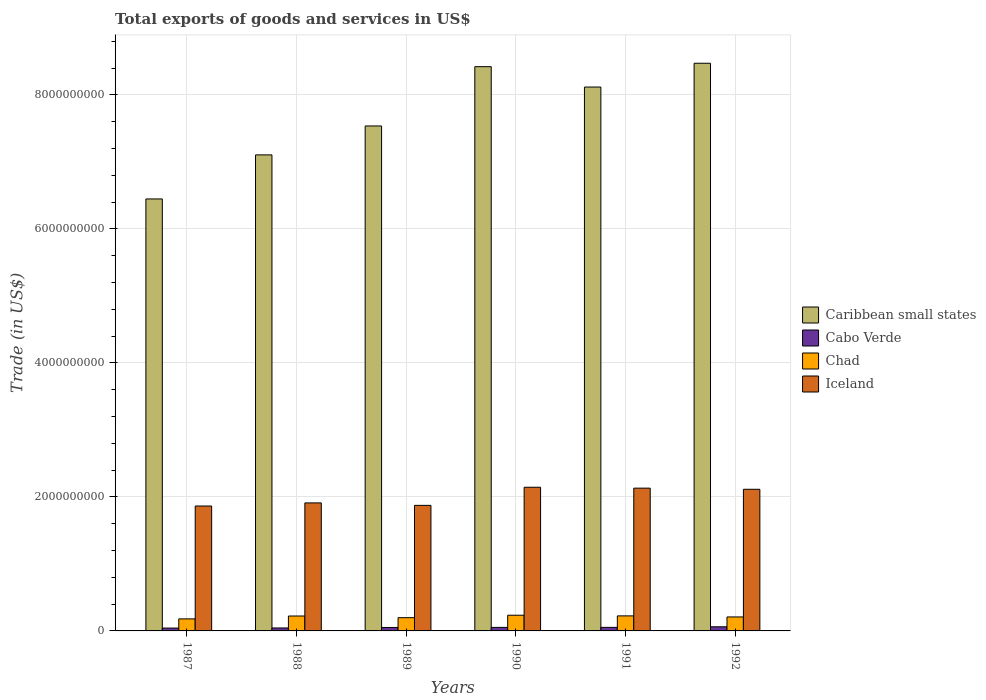How many different coloured bars are there?
Your answer should be compact. 4. How many groups of bars are there?
Your response must be concise. 6. Are the number of bars on each tick of the X-axis equal?
Make the answer very short. Yes. What is the total exports of goods and services in Caribbean small states in 1989?
Give a very brief answer. 7.54e+09. Across all years, what is the maximum total exports of goods and services in Cabo Verde?
Give a very brief answer. 6.17e+07. Across all years, what is the minimum total exports of goods and services in Iceland?
Offer a very short reply. 1.86e+09. In which year was the total exports of goods and services in Chad maximum?
Ensure brevity in your answer.  1990. What is the total total exports of goods and services in Cabo Verde in the graph?
Ensure brevity in your answer.  3.05e+08. What is the difference between the total exports of goods and services in Chad in 1987 and that in 1989?
Offer a very short reply. -1.78e+07. What is the difference between the total exports of goods and services in Chad in 1988 and the total exports of goods and services in Caribbean small states in 1990?
Ensure brevity in your answer.  -8.20e+09. What is the average total exports of goods and services in Chad per year?
Offer a terse response. 2.11e+08. In the year 1988, what is the difference between the total exports of goods and services in Cabo Verde and total exports of goods and services in Caribbean small states?
Provide a succinct answer. -7.06e+09. What is the ratio of the total exports of goods and services in Cabo Verde in 1989 to that in 1990?
Offer a very short reply. 0.98. Is the difference between the total exports of goods and services in Cabo Verde in 1987 and 1989 greater than the difference between the total exports of goods and services in Caribbean small states in 1987 and 1989?
Your response must be concise. Yes. What is the difference between the highest and the second highest total exports of goods and services in Cabo Verde?
Your answer should be compact. 8.75e+06. What is the difference between the highest and the lowest total exports of goods and services in Caribbean small states?
Give a very brief answer. 2.03e+09. What does the 3rd bar from the left in 1987 represents?
Your answer should be very brief. Chad. What does the 4th bar from the right in 1989 represents?
Your response must be concise. Caribbean small states. Is it the case that in every year, the sum of the total exports of goods and services in Cabo Verde and total exports of goods and services in Chad is greater than the total exports of goods and services in Iceland?
Your response must be concise. No. How many years are there in the graph?
Provide a short and direct response. 6. Are the values on the major ticks of Y-axis written in scientific E-notation?
Your answer should be very brief. No. Does the graph contain any zero values?
Provide a short and direct response. No. Does the graph contain grids?
Your answer should be compact. Yes. How are the legend labels stacked?
Offer a very short reply. Vertical. What is the title of the graph?
Give a very brief answer. Total exports of goods and services in US$. What is the label or title of the X-axis?
Make the answer very short. Years. What is the label or title of the Y-axis?
Provide a succinct answer. Trade (in US$). What is the Trade (in US$) in Caribbean small states in 1987?
Offer a terse response. 6.45e+09. What is the Trade (in US$) of Cabo Verde in 1987?
Provide a short and direct response. 4.26e+07. What is the Trade (in US$) in Chad in 1987?
Your answer should be compact. 1.80e+08. What is the Trade (in US$) of Iceland in 1987?
Offer a very short reply. 1.86e+09. What is the Trade (in US$) of Caribbean small states in 1988?
Make the answer very short. 7.11e+09. What is the Trade (in US$) of Cabo Verde in 1988?
Provide a succinct answer. 4.42e+07. What is the Trade (in US$) of Chad in 1988?
Your answer should be compact. 2.23e+08. What is the Trade (in US$) in Iceland in 1988?
Your response must be concise. 1.91e+09. What is the Trade (in US$) in Caribbean small states in 1989?
Keep it short and to the point. 7.54e+09. What is the Trade (in US$) in Cabo Verde in 1989?
Make the answer very short. 5.14e+07. What is the Trade (in US$) in Chad in 1989?
Ensure brevity in your answer.  1.98e+08. What is the Trade (in US$) of Iceland in 1989?
Ensure brevity in your answer.  1.87e+09. What is the Trade (in US$) in Caribbean small states in 1990?
Your answer should be compact. 8.42e+09. What is the Trade (in US$) of Cabo Verde in 1990?
Provide a short and direct response. 5.26e+07. What is the Trade (in US$) in Chad in 1990?
Give a very brief answer. 2.34e+08. What is the Trade (in US$) of Iceland in 1990?
Provide a succinct answer. 2.14e+09. What is the Trade (in US$) of Caribbean small states in 1991?
Ensure brevity in your answer.  8.12e+09. What is the Trade (in US$) of Cabo Verde in 1991?
Your response must be concise. 5.30e+07. What is the Trade (in US$) of Chad in 1991?
Offer a very short reply. 2.24e+08. What is the Trade (in US$) of Iceland in 1991?
Ensure brevity in your answer.  2.13e+09. What is the Trade (in US$) of Caribbean small states in 1992?
Give a very brief answer. 8.47e+09. What is the Trade (in US$) in Cabo Verde in 1992?
Your response must be concise. 6.17e+07. What is the Trade (in US$) in Chad in 1992?
Provide a succinct answer. 2.09e+08. What is the Trade (in US$) of Iceland in 1992?
Ensure brevity in your answer.  2.11e+09. Across all years, what is the maximum Trade (in US$) in Caribbean small states?
Your response must be concise. 8.47e+09. Across all years, what is the maximum Trade (in US$) in Cabo Verde?
Your answer should be compact. 6.17e+07. Across all years, what is the maximum Trade (in US$) in Chad?
Your answer should be compact. 2.34e+08. Across all years, what is the maximum Trade (in US$) in Iceland?
Make the answer very short. 2.14e+09. Across all years, what is the minimum Trade (in US$) of Caribbean small states?
Your answer should be compact. 6.45e+09. Across all years, what is the minimum Trade (in US$) of Cabo Verde?
Provide a short and direct response. 4.26e+07. Across all years, what is the minimum Trade (in US$) of Chad?
Ensure brevity in your answer.  1.80e+08. Across all years, what is the minimum Trade (in US$) of Iceland?
Offer a terse response. 1.86e+09. What is the total Trade (in US$) in Caribbean small states in the graph?
Your answer should be very brief. 4.61e+1. What is the total Trade (in US$) of Cabo Verde in the graph?
Ensure brevity in your answer.  3.05e+08. What is the total Trade (in US$) of Chad in the graph?
Provide a short and direct response. 1.27e+09. What is the total Trade (in US$) in Iceland in the graph?
Ensure brevity in your answer.  1.20e+1. What is the difference between the Trade (in US$) in Caribbean small states in 1987 and that in 1988?
Keep it short and to the point. -6.58e+08. What is the difference between the Trade (in US$) in Cabo Verde in 1987 and that in 1988?
Provide a succinct answer. -1.58e+06. What is the difference between the Trade (in US$) of Chad in 1987 and that in 1988?
Give a very brief answer. -4.29e+07. What is the difference between the Trade (in US$) in Iceland in 1987 and that in 1988?
Ensure brevity in your answer.  -4.64e+07. What is the difference between the Trade (in US$) in Caribbean small states in 1987 and that in 1989?
Your answer should be very brief. -1.09e+09. What is the difference between the Trade (in US$) in Cabo Verde in 1987 and that in 1989?
Make the answer very short. -8.84e+06. What is the difference between the Trade (in US$) of Chad in 1987 and that in 1989?
Your response must be concise. -1.78e+07. What is the difference between the Trade (in US$) of Iceland in 1987 and that in 1989?
Your answer should be very brief. -9.49e+06. What is the difference between the Trade (in US$) in Caribbean small states in 1987 and that in 1990?
Keep it short and to the point. -1.97e+09. What is the difference between the Trade (in US$) of Cabo Verde in 1987 and that in 1990?
Ensure brevity in your answer.  -1.00e+07. What is the difference between the Trade (in US$) of Chad in 1987 and that in 1990?
Your response must be concise. -5.46e+07. What is the difference between the Trade (in US$) of Iceland in 1987 and that in 1990?
Provide a succinct answer. -2.80e+08. What is the difference between the Trade (in US$) in Caribbean small states in 1987 and that in 1991?
Your answer should be very brief. -1.67e+09. What is the difference between the Trade (in US$) of Cabo Verde in 1987 and that in 1991?
Make the answer very short. -1.04e+07. What is the difference between the Trade (in US$) in Chad in 1987 and that in 1991?
Make the answer very short. -4.46e+07. What is the difference between the Trade (in US$) of Iceland in 1987 and that in 1991?
Provide a succinct answer. -2.66e+08. What is the difference between the Trade (in US$) in Caribbean small states in 1987 and that in 1992?
Your answer should be very brief. -2.03e+09. What is the difference between the Trade (in US$) of Cabo Verde in 1987 and that in 1992?
Keep it short and to the point. -1.91e+07. What is the difference between the Trade (in US$) in Chad in 1987 and that in 1992?
Your answer should be very brief. -2.90e+07. What is the difference between the Trade (in US$) of Iceland in 1987 and that in 1992?
Keep it short and to the point. -2.49e+08. What is the difference between the Trade (in US$) in Caribbean small states in 1988 and that in 1989?
Make the answer very short. -4.32e+08. What is the difference between the Trade (in US$) of Cabo Verde in 1988 and that in 1989?
Your answer should be compact. -7.26e+06. What is the difference between the Trade (in US$) of Chad in 1988 and that in 1989?
Give a very brief answer. 2.51e+07. What is the difference between the Trade (in US$) of Iceland in 1988 and that in 1989?
Give a very brief answer. 3.69e+07. What is the difference between the Trade (in US$) in Caribbean small states in 1988 and that in 1990?
Offer a terse response. -1.32e+09. What is the difference between the Trade (in US$) in Cabo Verde in 1988 and that in 1990?
Make the answer very short. -8.42e+06. What is the difference between the Trade (in US$) of Chad in 1988 and that in 1990?
Provide a succinct answer. -1.17e+07. What is the difference between the Trade (in US$) in Iceland in 1988 and that in 1990?
Give a very brief answer. -2.33e+08. What is the difference between the Trade (in US$) of Caribbean small states in 1988 and that in 1991?
Keep it short and to the point. -1.01e+09. What is the difference between the Trade (in US$) in Cabo Verde in 1988 and that in 1991?
Provide a succinct answer. -8.82e+06. What is the difference between the Trade (in US$) of Chad in 1988 and that in 1991?
Ensure brevity in your answer.  -1.68e+06. What is the difference between the Trade (in US$) of Iceland in 1988 and that in 1991?
Provide a succinct answer. -2.20e+08. What is the difference between the Trade (in US$) in Caribbean small states in 1988 and that in 1992?
Your response must be concise. -1.37e+09. What is the difference between the Trade (in US$) of Cabo Verde in 1988 and that in 1992?
Provide a short and direct response. -1.76e+07. What is the difference between the Trade (in US$) in Chad in 1988 and that in 1992?
Your answer should be very brief. 1.40e+07. What is the difference between the Trade (in US$) in Iceland in 1988 and that in 1992?
Provide a succinct answer. -2.03e+08. What is the difference between the Trade (in US$) of Caribbean small states in 1989 and that in 1990?
Keep it short and to the point. -8.85e+08. What is the difference between the Trade (in US$) of Cabo Verde in 1989 and that in 1990?
Provide a succinct answer. -1.16e+06. What is the difference between the Trade (in US$) in Chad in 1989 and that in 1990?
Your answer should be compact. -3.68e+07. What is the difference between the Trade (in US$) of Iceland in 1989 and that in 1990?
Offer a terse response. -2.70e+08. What is the difference between the Trade (in US$) of Caribbean small states in 1989 and that in 1991?
Provide a succinct answer. -5.81e+08. What is the difference between the Trade (in US$) in Cabo Verde in 1989 and that in 1991?
Offer a very short reply. -1.56e+06. What is the difference between the Trade (in US$) of Chad in 1989 and that in 1991?
Ensure brevity in your answer.  -2.68e+07. What is the difference between the Trade (in US$) of Iceland in 1989 and that in 1991?
Ensure brevity in your answer.  -2.57e+08. What is the difference between the Trade (in US$) of Caribbean small states in 1989 and that in 1992?
Offer a very short reply. -9.36e+08. What is the difference between the Trade (in US$) of Cabo Verde in 1989 and that in 1992?
Your response must be concise. -1.03e+07. What is the difference between the Trade (in US$) in Chad in 1989 and that in 1992?
Provide a short and direct response. -1.11e+07. What is the difference between the Trade (in US$) in Iceland in 1989 and that in 1992?
Keep it short and to the point. -2.40e+08. What is the difference between the Trade (in US$) of Caribbean small states in 1990 and that in 1991?
Ensure brevity in your answer.  3.04e+08. What is the difference between the Trade (in US$) in Cabo Verde in 1990 and that in 1991?
Your answer should be very brief. -4.00e+05. What is the difference between the Trade (in US$) in Chad in 1990 and that in 1991?
Provide a short and direct response. 1.00e+07. What is the difference between the Trade (in US$) in Iceland in 1990 and that in 1991?
Provide a short and direct response. 1.34e+07. What is the difference between the Trade (in US$) of Caribbean small states in 1990 and that in 1992?
Provide a succinct answer. -5.09e+07. What is the difference between the Trade (in US$) in Cabo Verde in 1990 and that in 1992?
Your response must be concise. -9.15e+06. What is the difference between the Trade (in US$) of Chad in 1990 and that in 1992?
Your answer should be very brief. 2.57e+07. What is the difference between the Trade (in US$) of Iceland in 1990 and that in 1992?
Offer a terse response. 3.05e+07. What is the difference between the Trade (in US$) in Caribbean small states in 1991 and that in 1992?
Offer a terse response. -3.55e+08. What is the difference between the Trade (in US$) of Cabo Verde in 1991 and that in 1992?
Provide a succinct answer. -8.75e+06. What is the difference between the Trade (in US$) of Chad in 1991 and that in 1992?
Offer a very short reply. 1.56e+07. What is the difference between the Trade (in US$) in Iceland in 1991 and that in 1992?
Keep it short and to the point. 1.71e+07. What is the difference between the Trade (in US$) in Caribbean small states in 1987 and the Trade (in US$) in Cabo Verde in 1988?
Provide a short and direct response. 6.40e+09. What is the difference between the Trade (in US$) of Caribbean small states in 1987 and the Trade (in US$) of Chad in 1988?
Ensure brevity in your answer.  6.22e+09. What is the difference between the Trade (in US$) in Caribbean small states in 1987 and the Trade (in US$) in Iceland in 1988?
Offer a terse response. 4.54e+09. What is the difference between the Trade (in US$) in Cabo Verde in 1987 and the Trade (in US$) in Chad in 1988?
Your answer should be very brief. -1.80e+08. What is the difference between the Trade (in US$) of Cabo Verde in 1987 and the Trade (in US$) of Iceland in 1988?
Make the answer very short. -1.87e+09. What is the difference between the Trade (in US$) of Chad in 1987 and the Trade (in US$) of Iceland in 1988?
Keep it short and to the point. -1.73e+09. What is the difference between the Trade (in US$) in Caribbean small states in 1987 and the Trade (in US$) in Cabo Verde in 1989?
Give a very brief answer. 6.40e+09. What is the difference between the Trade (in US$) in Caribbean small states in 1987 and the Trade (in US$) in Chad in 1989?
Provide a succinct answer. 6.25e+09. What is the difference between the Trade (in US$) in Caribbean small states in 1987 and the Trade (in US$) in Iceland in 1989?
Your answer should be compact. 4.57e+09. What is the difference between the Trade (in US$) of Cabo Verde in 1987 and the Trade (in US$) of Chad in 1989?
Offer a terse response. -1.55e+08. What is the difference between the Trade (in US$) of Cabo Verde in 1987 and the Trade (in US$) of Iceland in 1989?
Your response must be concise. -1.83e+09. What is the difference between the Trade (in US$) in Chad in 1987 and the Trade (in US$) in Iceland in 1989?
Make the answer very short. -1.69e+09. What is the difference between the Trade (in US$) of Caribbean small states in 1987 and the Trade (in US$) of Cabo Verde in 1990?
Offer a terse response. 6.40e+09. What is the difference between the Trade (in US$) in Caribbean small states in 1987 and the Trade (in US$) in Chad in 1990?
Make the answer very short. 6.21e+09. What is the difference between the Trade (in US$) of Caribbean small states in 1987 and the Trade (in US$) of Iceland in 1990?
Make the answer very short. 4.30e+09. What is the difference between the Trade (in US$) in Cabo Verde in 1987 and the Trade (in US$) in Chad in 1990?
Keep it short and to the point. -1.92e+08. What is the difference between the Trade (in US$) of Cabo Verde in 1987 and the Trade (in US$) of Iceland in 1990?
Make the answer very short. -2.10e+09. What is the difference between the Trade (in US$) of Chad in 1987 and the Trade (in US$) of Iceland in 1990?
Keep it short and to the point. -1.96e+09. What is the difference between the Trade (in US$) of Caribbean small states in 1987 and the Trade (in US$) of Cabo Verde in 1991?
Provide a succinct answer. 6.39e+09. What is the difference between the Trade (in US$) in Caribbean small states in 1987 and the Trade (in US$) in Chad in 1991?
Your response must be concise. 6.22e+09. What is the difference between the Trade (in US$) in Caribbean small states in 1987 and the Trade (in US$) in Iceland in 1991?
Make the answer very short. 4.32e+09. What is the difference between the Trade (in US$) of Cabo Verde in 1987 and the Trade (in US$) of Chad in 1991?
Keep it short and to the point. -1.82e+08. What is the difference between the Trade (in US$) of Cabo Verde in 1987 and the Trade (in US$) of Iceland in 1991?
Make the answer very short. -2.09e+09. What is the difference between the Trade (in US$) in Chad in 1987 and the Trade (in US$) in Iceland in 1991?
Offer a terse response. -1.95e+09. What is the difference between the Trade (in US$) in Caribbean small states in 1987 and the Trade (in US$) in Cabo Verde in 1992?
Offer a terse response. 6.39e+09. What is the difference between the Trade (in US$) of Caribbean small states in 1987 and the Trade (in US$) of Chad in 1992?
Give a very brief answer. 6.24e+09. What is the difference between the Trade (in US$) of Caribbean small states in 1987 and the Trade (in US$) of Iceland in 1992?
Offer a very short reply. 4.33e+09. What is the difference between the Trade (in US$) of Cabo Verde in 1987 and the Trade (in US$) of Chad in 1992?
Your answer should be very brief. -1.66e+08. What is the difference between the Trade (in US$) of Cabo Verde in 1987 and the Trade (in US$) of Iceland in 1992?
Make the answer very short. -2.07e+09. What is the difference between the Trade (in US$) in Chad in 1987 and the Trade (in US$) in Iceland in 1992?
Provide a short and direct response. -1.93e+09. What is the difference between the Trade (in US$) of Caribbean small states in 1988 and the Trade (in US$) of Cabo Verde in 1989?
Your response must be concise. 7.05e+09. What is the difference between the Trade (in US$) of Caribbean small states in 1988 and the Trade (in US$) of Chad in 1989?
Make the answer very short. 6.91e+09. What is the difference between the Trade (in US$) of Caribbean small states in 1988 and the Trade (in US$) of Iceland in 1989?
Provide a succinct answer. 5.23e+09. What is the difference between the Trade (in US$) of Cabo Verde in 1988 and the Trade (in US$) of Chad in 1989?
Ensure brevity in your answer.  -1.53e+08. What is the difference between the Trade (in US$) in Cabo Verde in 1988 and the Trade (in US$) in Iceland in 1989?
Ensure brevity in your answer.  -1.83e+09. What is the difference between the Trade (in US$) of Chad in 1988 and the Trade (in US$) of Iceland in 1989?
Offer a terse response. -1.65e+09. What is the difference between the Trade (in US$) in Caribbean small states in 1988 and the Trade (in US$) in Cabo Verde in 1990?
Your response must be concise. 7.05e+09. What is the difference between the Trade (in US$) of Caribbean small states in 1988 and the Trade (in US$) of Chad in 1990?
Ensure brevity in your answer.  6.87e+09. What is the difference between the Trade (in US$) of Caribbean small states in 1988 and the Trade (in US$) of Iceland in 1990?
Provide a short and direct response. 4.96e+09. What is the difference between the Trade (in US$) of Cabo Verde in 1988 and the Trade (in US$) of Chad in 1990?
Keep it short and to the point. -1.90e+08. What is the difference between the Trade (in US$) in Cabo Verde in 1988 and the Trade (in US$) in Iceland in 1990?
Provide a short and direct response. -2.10e+09. What is the difference between the Trade (in US$) in Chad in 1988 and the Trade (in US$) in Iceland in 1990?
Keep it short and to the point. -1.92e+09. What is the difference between the Trade (in US$) of Caribbean small states in 1988 and the Trade (in US$) of Cabo Verde in 1991?
Ensure brevity in your answer.  7.05e+09. What is the difference between the Trade (in US$) of Caribbean small states in 1988 and the Trade (in US$) of Chad in 1991?
Keep it short and to the point. 6.88e+09. What is the difference between the Trade (in US$) in Caribbean small states in 1988 and the Trade (in US$) in Iceland in 1991?
Ensure brevity in your answer.  4.97e+09. What is the difference between the Trade (in US$) in Cabo Verde in 1988 and the Trade (in US$) in Chad in 1991?
Give a very brief answer. -1.80e+08. What is the difference between the Trade (in US$) of Cabo Verde in 1988 and the Trade (in US$) of Iceland in 1991?
Your answer should be compact. -2.09e+09. What is the difference between the Trade (in US$) in Chad in 1988 and the Trade (in US$) in Iceland in 1991?
Your answer should be compact. -1.91e+09. What is the difference between the Trade (in US$) of Caribbean small states in 1988 and the Trade (in US$) of Cabo Verde in 1992?
Ensure brevity in your answer.  7.04e+09. What is the difference between the Trade (in US$) in Caribbean small states in 1988 and the Trade (in US$) in Chad in 1992?
Your answer should be very brief. 6.90e+09. What is the difference between the Trade (in US$) of Caribbean small states in 1988 and the Trade (in US$) of Iceland in 1992?
Your response must be concise. 4.99e+09. What is the difference between the Trade (in US$) of Cabo Verde in 1988 and the Trade (in US$) of Chad in 1992?
Your answer should be compact. -1.65e+08. What is the difference between the Trade (in US$) of Cabo Verde in 1988 and the Trade (in US$) of Iceland in 1992?
Offer a very short reply. -2.07e+09. What is the difference between the Trade (in US$) of Chad in 1988 and the Trade (in US$) of Iceland in 1992?
Give a very brief answer. -1.89e+09. What is the difference between the Trade (in US$) in Caribbean small states in 1989 and the Trade (in US$) in Cabo Verde in 1990?
Offer a terse response. 7.48e+09. What is the difference between the Trade (in US$) of Caribbean small states in 1989 and the Trade (in US$) of Chad in 1990?
Give a very brief answer. 7.30e+09. What is the difference between the Trade (in US$) of Caribbean small states in 1989 and the Trade (in US$) of Iceland in 1990?
Offer a very short reply. 5.39e+09. What is the difference between the Trade (in US$) of Cabo Verde in 1989 and the Trade (in US$) of Chad in 1990?
Give a very brief answer. -1.83e+08. What is the difference between the Trade (in US$) of Cabo Verde in 1989 and the Trade (in US$) of Iceland in 1990?
Offer a very short reply. -2.09e+09. What is the difference between the Trade (in US$) in Chad in 1989 and the Trade (in US$) in Iceland in 1990?
Make the answer very short. -1.95e+09. What is the difference between the Trade (in US$) in Caribbean small states in 1989 and the Trade (in US$) in Cabo Verde in 1991?
Provide a short and direct response. 7.48e+09. What is the difference between the Trade (in US$) of Caribbean small states in 1989 and the Trade (in US$) of Chad in 1991?
Provide a succinct answer. 7.31e+09. What is the difference between the Trade (in US$) in Caribbean small states in 1989 and the Trade (in US$) in Iceland in 1991?
Give a very brief answer. 5.41e+09. What is the difference between the Trade (in US$) in Cabo Verde in 1989 and the Trade (in US$) in Chad in 1991?
Provide a short and direct response. -1.73e+08. What is the difference between the Trade (in US$) of Cabo Verde in 1989 and the Trade (in US$) of Iceland in 1991?
Provide a short and direct response. -2.08e+09. What is the difference between the Trade (in US$) of Chad in 1989 and the Trade (in US$) of Iceland in 1991?
Give a very brief answer. -1.93e+09. What is the difference between the Trade (in US$) of Caribbean small states in 1989 and the Trade (in US$) of Cabo Verde in 1992?
Provide a succinct answer. 7.48e+09. What is the difference between the Trade (in US$) of Caribbean small states in 1989 and the Trade (in US$) of Chad in 1992?
Give a very brief answer. 7.33e+09. What is the difference between the Trade (in US$) of Caribbean small states in 1989 and the Trade (in US$) of Iceland in 1992?
Your answer should be very brief. 5.42e+09. What is the difference between the Trade (in US$) in Cabo Verde in 1989 and the Trade (in US$) in Chad in 1992?
Offer a very short reply. -1.57e+08. What is the difference between the Trade (in US$) of Cabo Verde in 1989 and the Trade (in US$) of Iceland in 1992?
Offer a very short reply. -2.06e+09. What is the difference between the Trade (in US$) of Chad in 1989 and the Trade (in US$) of Iceland in 1992?
Your answer should be very brief. -1.92e+09. What is the difference between the Trade (in US$) in Caribbean small states in 1990 and the Trade (in US$) in Cabo Verde in 1991?
Make the answer very short. 8.37e+09. What is the difference between the Trade (in US$) in Caribbean small states in 1990 and the Trade (in US$) in Chad in 1991?
Your answer should be very brief. 8.20e+09. What is the difference between the Trade (in US$) in Caribbean small states in 1990 and the Trade (in US$) in Iceland in 1991?
Offer a terse response. 6.29e+09. What is the difference between the Trade (in US$) in Cabo Verde in 1990 and the Trade (in US$) in Chad in 1991?
Provide a short and direct response. -1.72e+08. What is the difference between the Trade (in US$) in Cabo Verde in 1990 and the Trade (in US$) in Iceland in 1991?
Offer a terse response. -2.08e+09. What is the difference between the Trade (in US$) in Chad in 1990 and the Trade (in US$) in Iceland in 1991?
Your answer should be compact. -1.90e+09. What is the difference between the Trade (in US$) in Caribbean small states in 1990 and the Trade (in US$) in Cabo Verde in 1992?
Make the answer very short. 8.36e+09. What is the difference between the Trade (in US$) of Caribbean small states in 1990 and the Trade (in US$) of Chad in 1992?
Keep it short and to the point. 8.21e+09. What is the difference between the Trade (in US$) in Caribbean small states in 1990 and the Trade (in US$) in Iceland in 1992?
Your answer should be very brief. 6.31e+09. What is the difference between the Trade (in US$) in Cabo Verde in 1990 and the Trade (in US$) in Chad in 1992?
Give a very brief answer. -1.56e+08. What is the difference between the Trade (in US$) in Cabo Verde in 1990 and the Trade (in US$) in Iceland in 1992?
Make the answer very short. -2.06e+09. What is the difference between the Trade (in US$) of Chad in 1990 and the Trade (in US$) of Iceland in 1992?
Make the answer very short. -1.88e+09. What is the difference between the Trade (in US$) in Caribbean small states in 1991 and the Trade (in US$) in Cabo Verde in 1992?
Your response must be concise. 8.06e+09. What is the difference between the Trade (in US$) in Caribbean small states in 1991 and the Trade (in US$) in Chad in 1992?
Give a very brief answer. 7.91e+09. What is the difference between the Trade (in US$) of Caribbean small states in 1991 and the Trade (in US$) of Iceland in 1992?
Provide a succinct answer. 6.00e+09. What is the difference between the Trade (in US$) in Cabo Verde in 1991 and the Trade (in US$) in Chad in 1992?
Ensure brevity in your answer.  -1.56e+08. What is the difference between the Trade (in US$) in Cabo Verde in 1991 and the Trade (in US$) in Iceland in 1992?
Your answer should be compact. -2.06e+09. What is the difference between the Trade (in US$) of Chad in 1991 and the Trade (in US$) of Iceland in 1992?
Ensure brevity in your answer.  -1.89e+09. What is the average Trade (in US$) in Caribbean small states per year?
Provide a short and direct response. 7.68e+09. What is the average Trade (in US$) of Cabo Verde per year?
Offer a terse response. 5.09e+07. What is the average Trade (in US$) in Chad per year?
Your response must be concise. 2.11e+08. What is the average Trade (in US$) in Iceland per year?
Make the answer very short. 2.01e+09. In the year 1987, what is the difference between the Trade (in US$) in Caribbean small states and Trade (in US$) in Cabo Verde?
Give a very brief answer. 6.41e+09. In the year 1987, what is the difference between the Trade (in US$) of Caribbean small states and Trade (in US$) of Chad?
Your answer should be compact. 6.27e+09. In the year 1987, what is the difference between the Trade (in US$) of Caribbean small states and Trade (in US$) of Iceland?
Your response must be concise. 4.58e+09. In the year 1987, what is the difference between the Trade (in US$) in Cabo Verde and Trade (in US$) in Chad?
Your answer should be very brief. -1.37e+08. In the year 1987, what is the difference between the Trade (in US$) of Cabo Verde and Trade (in US$) of Iceland?
Your response must be concise. -1.82e+09. In the year 1987, what is the difference between the Trade (in US$) of Chad and Trade (in US$) of Iceland?
Your answer should be compact. -1.68e+09. In the year 1988, what is the difference between the Trade (in US$) of Caribbean small states and Trade (in US$) of Cabo Verde?
Offer a very short reply. 7.06e+09. In the year 1988, what is the difference between the Trade (in US$) in Caribbean small states and Trade (in US$) in Chad?
Offer a terse response. 6.88e+09. In the year 1988, what is the difference between the Trade (in US$) of Caribbean small states and Trade (in US$) of Iceland?
Your response must be concise. 5.19e+09. In the year 1988, what is the difference between the Trade (in US$) of Cabo Verde and Trade (in US$) of Chad?
Keep it short and to the point. -1.79e+08. In the year 1988, what is the difference between the Trade (in US$) in Cabo Verde and Trade (in US$) in Iceland?
Keep it short and to the point. -1.87e+09. In the year 1988, what is the difference between the Trade (in US$) in Chad and Trade (in US$) in Iceland?
Provide a short and direct response. -1.69e+09. In the year 1989, what is the difference between the Trade (in US$) in Caribbean small states and Trade (in US$) in Cabo Verde?
Give a very brief answer. 7.49e+09. In the year 1989, what is the difference between the Trade (in US$) of Caribbean small states and Trade (in US$) of Chad?
Your response must be concise. 7.34e+09. In the year 1989, what is the difference between the Trade (in US$) of Caribbean small states and Trade (in US$) of Iceland?
Provide a succinct answer. 5.66e+09. In the year 1989, what is the difference between the Trade (in US$) of Cabo Verde and Trade (in US$) of Chad?
Provide a succinct answer. -1.46e+08. In the year 1989, what is the difference between the Trade (in US$) in Cabo Verde and Trade (in US$) in Iceland?
Provide a succinct answer. -1.82e+09. In the year 1989, what is the difference between the Trade (in US$) of Chad and Trade (in US$) of Iceland?
Keep it short and to the point. -1.68e+09. In the year 1990, what is the difference between the Trade (in US$) of Caribbean small states and Trade (in US$) of Cabo Verde?
Your response must be concise. 8.37e+09. In the year 1990, what is the difference between the Trade (in US$) of Caribbean small states and Trade (in US$) of Chad?
Ensure brevity in your answer.  8.19e+09. In the year 1990, what is the difference between the Trade (in US$) in Caribbean small states and Trade (in US$) in Iceland?
Ensure brevity in your answer.  6.28e+09. In the year 1990, what is the difference between the Trade (in US$) in Cabo Verde and Trade (in US$) in Chad?
Keep it short and to the point. -1.82e+08. In the year 1990, what is the difference between the Trade (in US$) in Cabo Verde and Trade (in US$) in Iceland?
Give a very brief answer. -2.09e+09. In the year 1990, what is the difference between the Trade (in US$) of Chad and Trade (in US$) of Iceland?
Give a very brief answer. -1.91e+09. In the year 1991, what is the difference between the Trade (in US$) in Caribbean small states and Trade (in US$) in Cabo Verde?
Your answer should be very brief. 8.07e+09. In the year 1991, what is the difference between the Trade (in US$) of Caribbean small states and Trade (in US$) of Chad?
Give a very brief answer. 7.89e+09. In the year 1991, what is the difference between the Trade (in US$) of Caribbean small states and Trade (in US$) of Iceland?
Ensure brevity in your answer.  5.99e+09. In the year 1991, what is the difference between the Trade (in US$) of Cabo Verde and Trade (in US$) of Chad?
Ensure brevity in your answer.  -1.71e+08. In the year 1991, what is the difference between the Trade (in US$) in Cabo Verde and Trade (in US$) in Iceland?
Give a very brief answer. -2.08e+09. In the year 1991, what is the difference between the Trade (in US$) of Chad and Trade (in US$) of Iceland?
Your answer should be compact. -1.91e+09. In the year 1992, what is the difference between the Trade (in US$) in Caribbean small states and Trade (in US$) in Cabo Verde?
Your answer should be compact. 8.41e+09. In the year 1992, what is the difference between the Trade (in US$) in Caribbean small states and Trade (in US$) in Chad?
Make the answer very short. 8.26e+09. In the year 1992, what is the difference between the Trade (in US$) of Caribbean small states and Trade (in US$) of Iceland?
Provide a short and direct response. 6.36e+09. In the year 1992, what is the difference between the Trade (in US$) in Cabo Verde and Trade (in US$) in Chad?
Keep it short and to the point. -1.47e+08. In the year 1992, what is the difference between the Trade (in US$) in Cabo Verde and Trade (in US$) in Iceland?
Keep it short and to the point. -2.05e+09. In the year 1992, what is the difference between the Trade (in US$) in Chad and Trade (in US$) in Iceland?
Make the answer very short. -1.91e+09. What is the ratio of the Trade (in US$) of Caribbean small states in 1987 to that in 1988?
Offer a terse response. 0.91. What is the ratio of the Trade (in US$) in Cabo Verde in 1987 to that in 1988?
Offer a terse response. 0.96. What is the ratio of the Trade (in US$) in Chad in 1987 to that in 1988?
Give a very brief answer. 0.81. What is the ratio of the Trade (in US$) of Iceland in 1987 to that in 1988?
Offer a very short reply. 0.98. What is the ratio of the Trade (in US$) in Caribbean small states in 1987 to that in 1989?
Your answer should be compact. 0.86. What is the ratio of the Trade (in US$) of Cabo Verde in 1987 to that in 1989?
Provide a short and direct response. 0.83. What is the ratio of the Trade (in US$) of Chad in 1987 to that in 1989?
Ensure brevity in your answer.  0.91. What is the ratio of the Trade (in US$) in Caribbean small states in 1987 to that in 1990?
Offer a terse response. 0.77. What is the ratio of the Trade (in US$) in Cabo Verde in 1987 to that in 1990?
Your answer should be very brief. 0.81. What is the ratio of the Trade (in US$) of Chad in 1987 to that in 1990?
Your answer should be very brief. 0.77. What is the ratio of the Trade (in US$) in Iceland in 1987 to that in 1990?
Offer a very short reply. 0.87. What is the ratio of the Trade (in US$) of Caribbean small states in 1987 to that in 1991?
Offer a very short reply. 0.79. What is the ratio of the Trade (in US$) in Cabo Verde in 1987 to that in 1991?
Make the answer very short. 0.8. What is the ratio of the Trade (in US$) of Chad in 1987 to that in 1991?
Keep it short and to the point. 0.8. What is the ratio of the Trade (in US$) of Iceland in 1987 to that in 1991?
Provide a short and direct response. 0.88. What is the ratio of the Trade (in US$) of Caribbean small states in 1987 to that in 1992?
Ensure brevity in your answer.  0.76. What is the ratio of the Trade (in US$) in Cabo Verde in 1987 to that in 1992?
Your response must be concise. 0.69. What is the ratio of the Trade (in US$) in Chad in 1987 to that in 1992?
Your answer should be very brief. 0.86. What is the ratio of the Trade (in US$) in Iceland in 1987 to that in 1992?
Your response must be concise. 0.88. What is the ratio of the Trade (in US$) of Caribbean small states in 1988 to that in 1989?
Your answer should be very brief. 0.94. What is the ratio of the Trade (in US$) of Cabo Verde in 1988 to that in 1989?
Offer a very short reply. 0.86. What is the ratio of the Trade (in US$) in Chad in 1988 to that in 1989?
Provide a short and direct response. 1.13. What is the ratio of the Trade (in US$) in Iceland in 1988 to that in 1989?
Keep it short and to the point. 1.02. What is the ratio of the Trade (in US$) of Caribbean small states in 1988 to that in 1990?
Provide a succinct answer. 0.84. What is the ratio of the Trade (in US$) of Cabo Verde in 1988 to that in 1990?
Make the answer very short. 0.84. What is the ratio of the Trade (in US$) in Chad in 1988 to that in 1990?
Offer a very short reply. 0.95. What is the ratio of the Trade (in US$) of Iceland in 1988 to that in 1990?
Provide a short and direct response. 0.89. What is the ratio of the Trade (in US$) of Caribbean small states in 1988 to that in 1991?
Provide a short and direct response. 0.88. What is the ratio of the Trade (in US$) in Cabo Verde in 1988 to that in 1991?
Ensure brevity in your answer.  0.83. What is the ratio of the Trade (in US$) of Iceland in 1988 to that in 1991?
Offer a terse response. 0.9. What is the ratio of the Trade (in US$) of Caribbean small states in 1988 to that in 1992?
Provide a succinct answer. 0.84. What is the ratio of the Trade (in US$) in Cabo Verde in 1988 to that in 1992?
Make the answer very short. 0.72. What is the ratio of the Trade (in US$) of Chad in 1988 to that in 1992?
Offer a terse response. 1.07. What is the ratio of the Trade (in US$) of Iceland in 1988 to that in 1992?
Ensure brevity in your answer.  0.9. What is the ratio of the Trade (in US$) in Caribbean small states in 1989 to that in 1990?
Ensure brevity in your answer.  0.89. What is the ratio of the Trade (in US$) in Cabo Verde in 1989 to that in 1990?
Your response must be concise. 0.98. What is the ratio of the Trade (in US$) of Chad in 1989 to that in 1990?
Provide a short and direct response. 0.84. What is the ratio of the Trade (in US$) of Iceland in 1989 to that in 1990?
Your answer should be very brief. 0.87. What is the ratio of the Trade (in US$) in Caribbean small states in 1989 to that in 1991?
Make the answer very short. 0.93. What is the ratio of the Trade (in US$) in Cabo Verde in 1989 to that in 1991?
Provide a succinct answer. 0.97. What is the ratio of the Trade (in US$) in Chad in 1989 to that in 1991?
Your answer should be very brief. 0.88. What is the ratio of the Trade (in US$) of Iceland in 1989 to that in 1991?
Keep it short and to the point. 0.88. What is the ratio of the Trade (in US$) in Caribbean small states in 1989 to that in 1992?
Your answer should be very brief. 0.89. What is the ratio of the Trade (in US$) in Cabo Verde in 1989 to that in 1992?
Make the answer very short. 0.83. What is the ratio of the Trade (in US$) of Chad in 1989 to that in 1992?
Offer a terse response. 0.95. What is the ratio of the Trade (in US$) in Iceland in 1989 to that in 1992?
Offer a terse response. 0.89. What is the ratio of the Trade (in US$) in Caribbean small states in 1990 to that in 1991?
Provide a succinct answer. 1.04. What is the ratio of the Trade (in US$) in Cabo Verde in 1990 to that in 1991?
Your answer should be compact. 0.99. What is the ratio of the Trade (in US$) of Chad in 1990 to that in 1991?
Provide a short and direct response. 1.04. What is the ratio of the Trade (in US$) of Cabo Verde in 1990 to that in 1992?
Keep it short and to the point. 0.85. What is the ratio of the Trade (in US$) of Chad in 1990 to that in 1992?
Your response must be concise. 1.12. What is the ratio of the Trade (in US$) in Iceland in 1990 to that in 1992?
Keep it short and to the point. 1.01. What is the ratio of the Trade (in US$) of Caribbean small states in 1991 to that in 1992?
Provide a short and direct response. 0.96. What is the ratio of the Trade (in US$) of Cabo Verde in 1991 to that in 1992?
Your answer should be compact. 0.86. What is the ratio of the Trade (in US$) of Chad in 1991 to that in 1992?
Provide a short and direct response. 1.07. What is the difference between the highest and the second highest Trade (in US$) in Caribbean small states?
Your answer should be compact. 5.09e+07. What is the difference between the highest and the second highest Trade (in US$) of Cabo Verde?
Provide a short and direct response. 8.75e+06. What is the difference between the highest and the second highest Trade (in US$) in Chad?
Offer a terse response. 1.00e+07. What is the difference between the highest and the second highest Trade (in US$) in Iceland?
Your answer should be very brief. 1.34e+07. What is the difference between the highest and the lowest Trade (in US$) of Caribbean small states?
Make the answer very short. 2.03e+09. What is the difference between the highest and the lowest Trade (in US$) of Cabo Verde?
Offer a terse response. 1.91e+07. What is the difference between the highest and the lowest Trade (in US$) of Chad?
Make the answer very short. 5.46e+07. What is the difference between the highest and the lowest Trade (in US$) of Iceland?
Ensure brevity in your answer.  2.80e+08. 